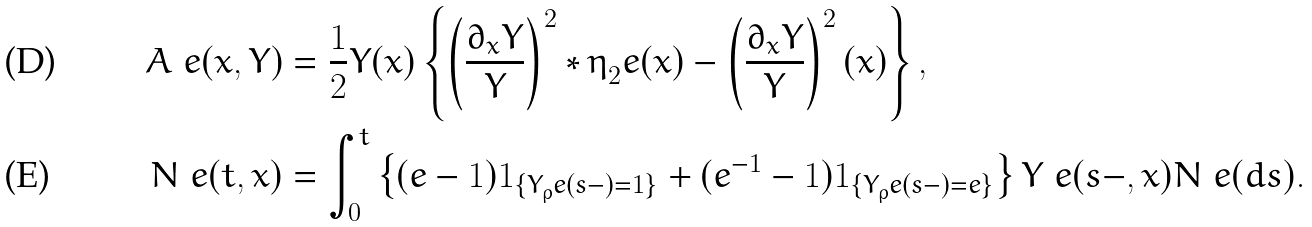Convert formula to latex. <formula><loc_0><loc_0><loc_500><loc_500>A ^ { \ } e ( x , Y ) & = \frac { 1 } { 2 } Y ( x ) \left \{ \left ( \frac { \partial _ { x } Y } Y \right ) ^ { 2 } * \eta _ { 2 } ^ { \ } e ( x ) - \left ( \frac { \partial _ { x } Y } Y \right ) ^ { 2 } ( x ) \right \} , \\ N ^ { \ } e ( t , x ) & = \int _ { 0 } ^ { t } \left \{ ( e - 1 ) 1 _ { \{ Y _ { \rho } ^ { \ } e ( s - ) = 1 \} } + ( e ^ { - 1 } - 1 ) 1 _ { \{ Y _ { \rho } ^ { \ } e ( s - ) = e \} } \right \} Y ^ { \ } e ( s - , x ) N ^ { \ } e ( d s ) .</formula> 